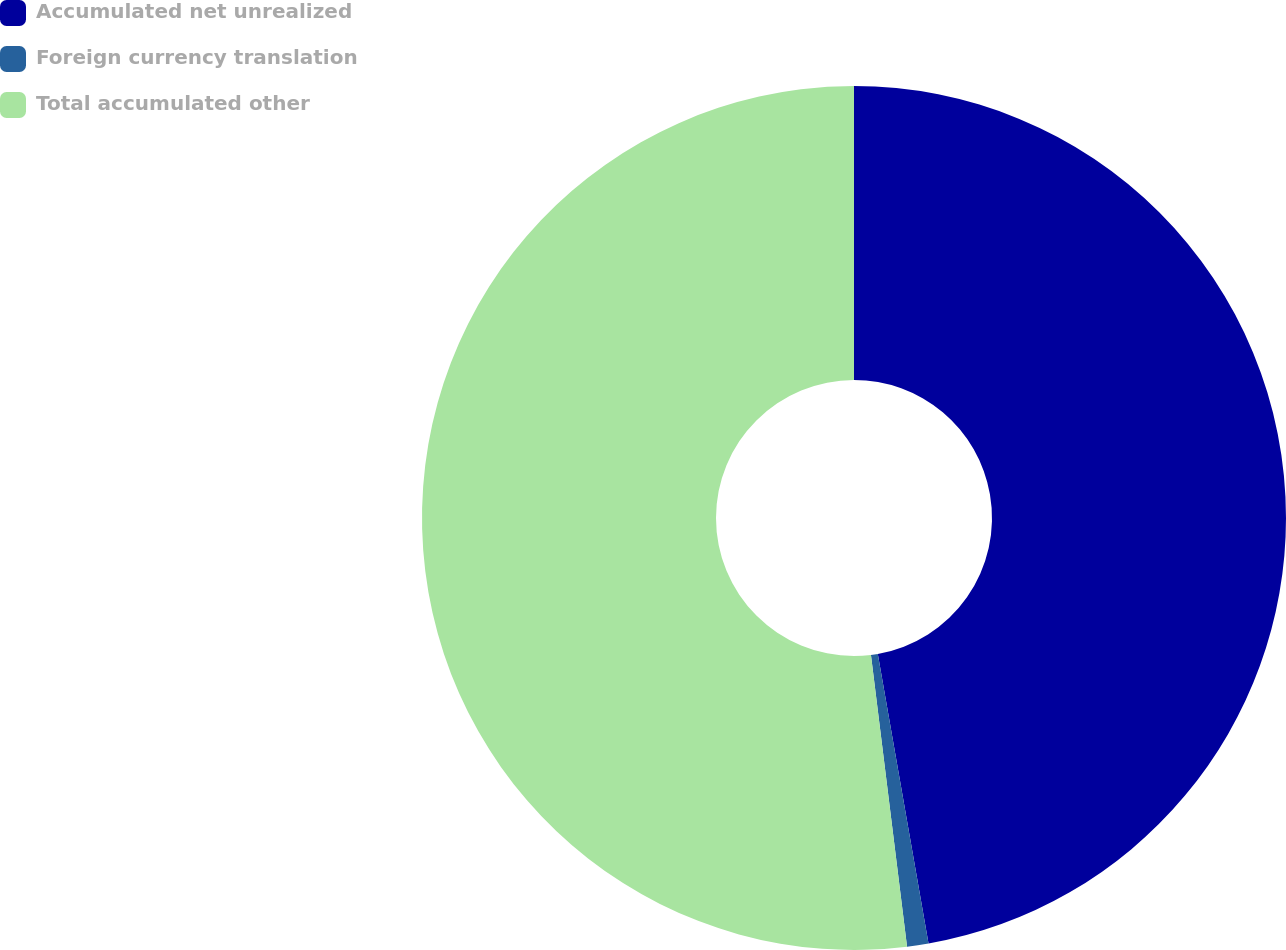Convert chart to OTSL. <chart><loc_0><loc_0><loc_500><loc_500><pie_chart><fcel>Accumulated net unrealized<fcel>Foreign currency translation<fcel>Total accumulated other<nl><fcel>47.24%<fcel>0.8%<fcel>51.96%<nl></chart> 